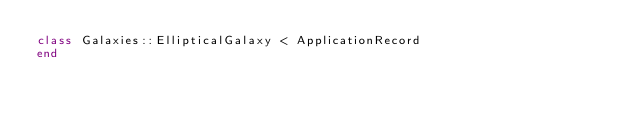Convert code to text. <code><loc_0><loc_0><loc_500><loc_500><_Ruby_>class Galaxies::EllipticalGalaxy < ApplicationRecord
end
</code> 